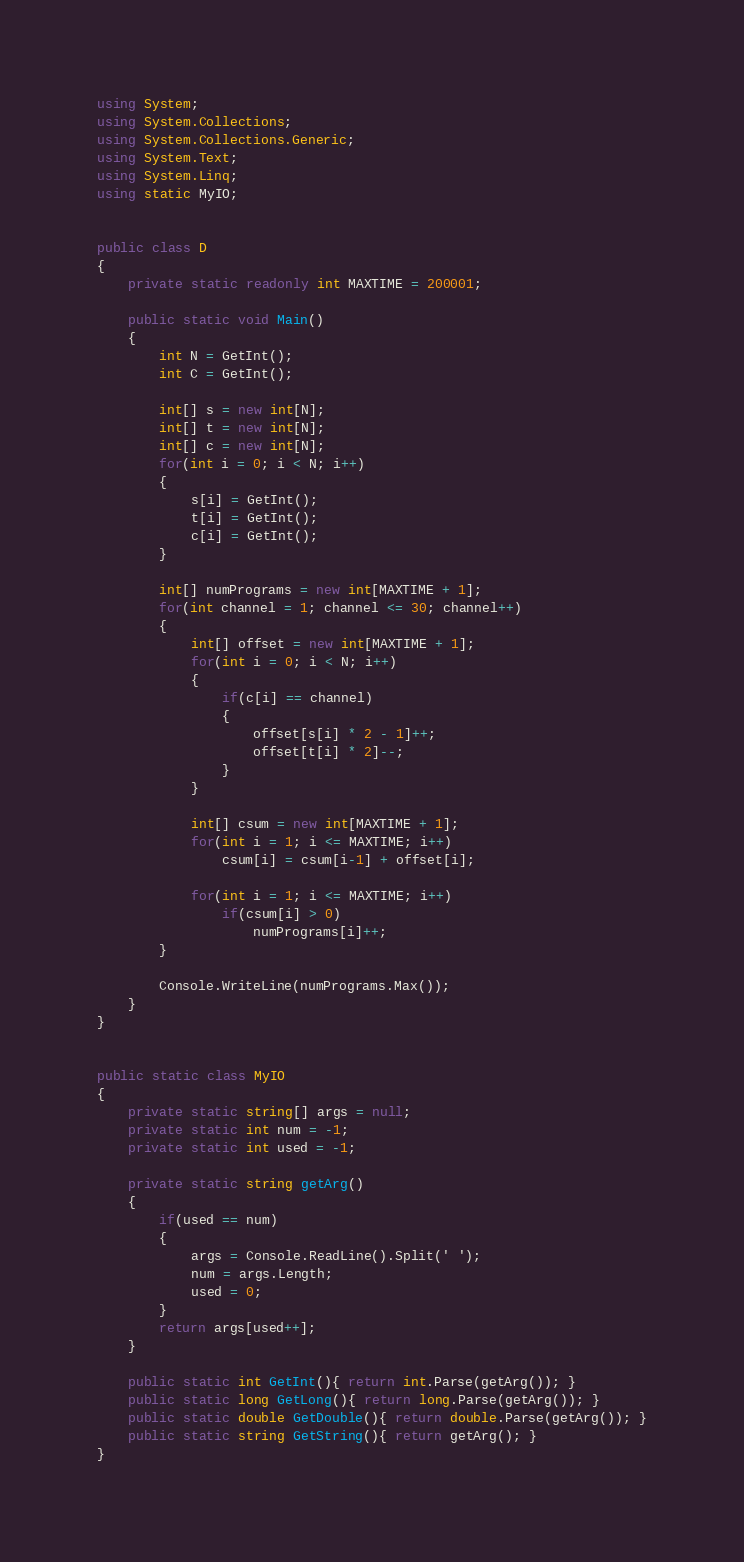<code> <loc_0><loc_0><loc_500><loc_500><_C#_>using System;
using System.Collections;
using System.Collections.Generic;
using System.Text;
using System.Linq;
using static MyIO;


public class D
{
	private static readonly int MAXTIME = 200001;

	public static void Main()
	{
		int N = GetInt();
		int C = GetInt();

		int[] s = new int[N];
		int[] t = new int[N];
		int[] c = new int[N];
		for(int i = 0; i < N; i++)
		{
			s[i] = GetInt();
			t[i] = GetInt();
			c[i] = GetInt();
		}

		int[] numPrograms = new int[MAXTIME + 1];
		for(int channel = 1; channel <= 30; channel++)
		{
			int[] offset = new int[MAXTIME + 1];
			for(int i = 0; i < N; i++)
			{
				if(c[i] == channel)
				{
					offset[s[i] * 2 - 1]++;
					offset[t[i] * 2]--;
				}
			}
			
			int[] csum = new int[MAXTIME + 1];
			for(int i = 1; i <= MAXTIME; i++)
				csum[i] = csum[i-1] + offset[i];

			for(int i = 1; i <= MAXTIME; i++)
				if(csum[i] > 0)
					numPrograms[i]++;
		}

		Console.WriteLine(numPrograms.Max());
	}
}


public static class MyIO
{
	private static string[] args = null;
	private static int num = -1;
	private static int used = -1;

	private static string getArg()
	{
		if(used == num)
		{
			args = Console.ReadLine().Split(' ');
			num = args.Length;
			used = 0;
		}
		return args[used++];
	}

	public static int GetInt(){ return int.Parse(getArg()); }
	public static long GetLong(){ return long.Parse(getArg()); }
	public static double GetDouble(){ return double.Parse(getArg()); }
	public static string GetString(){ return getArg(); }
}



</code> 